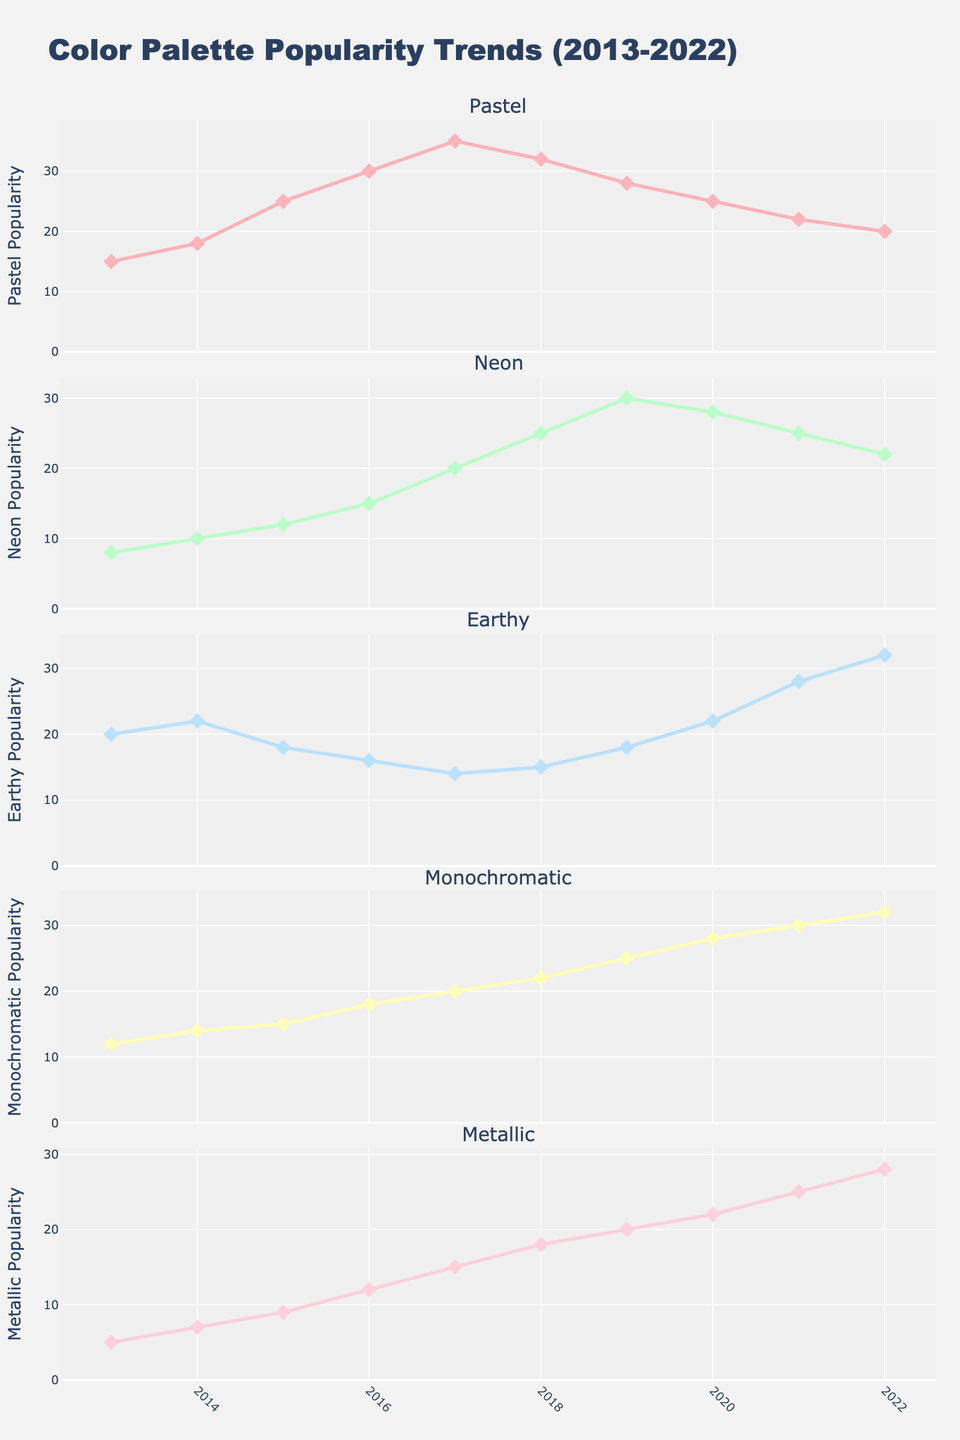what is the title of the figure? The title is often prominently displayed at the top of the figure. By observing the figure, the title can usually be found in bold or larger font.
Answer: Color Palette Popularity Trends (2013-2022) which color palette was the most popular in 2016? Look at each subplot and find the highest value for the year 2016 across all the palettes. The highest peak indicates the most popular palette that year.
Answer: Pastel how many color palettes are tracked in the figure? Check the subplot titles or the legend to count the number of distinct color palettes shown. Each subplot represents one palette.
Answer: 5 during which year did the monochromatic palette see the highest popularity? By focusing on the Monochromatic subplot, identify the year with the highest value indicated by the peak of the line.
Answer: 2022 which two color palettes had the closest popularity values in 2018? Compare the values of all the palettes for the year 2018. The palettes with the smallest difference between their values are the closest.
Answer: Earthy and Monochromatic what is the overall trend for the neon palette over the decade? Track the line representing Neon across the years to see if it generally rises, falls, or remains stable.
Answer: Increasing which year saw the greatest increase in popularity for the pastel palette compared to the previous year? Calculate the differences between consecutive years for the Pastel subplot and identify the year with the greatest positive difference.
Answer: 2016 how does the metallic palette's popularity in 2019 compare to that in 2013? Find the values for the Metallic palette in both 2019 and 2013 and compare them.
Answer: Higher in 2019 which palette showed a consistent year-over-year increase? Check each palette to see which one increases every year without any drop.
Answer: Monochromatic what was the approximate combined popularity of all palettes in 2017? Add the values of all the palettes for the year 2017 to get the total popularity.
Answer: 104 